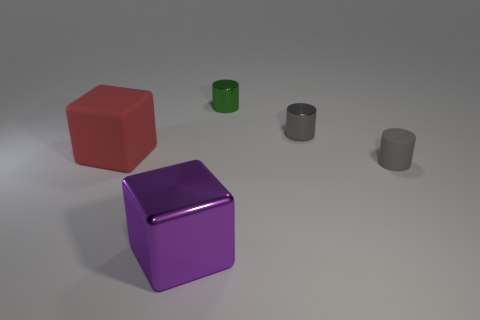Add 2 large purple shiny objects. How many objects exist? 7 Subtract all blocks. How many objects are left? 3 Add 1 large red rubber objects. How many large red rubber objects exist? 2 Subtract 0 brown cubes. How many objects are left? 5 Subtract all gray metal cylinders. Subtract all big green matte spheres. How many objects are left? 4 Add 5 red rubber things. How many red rubber things are left? 6 